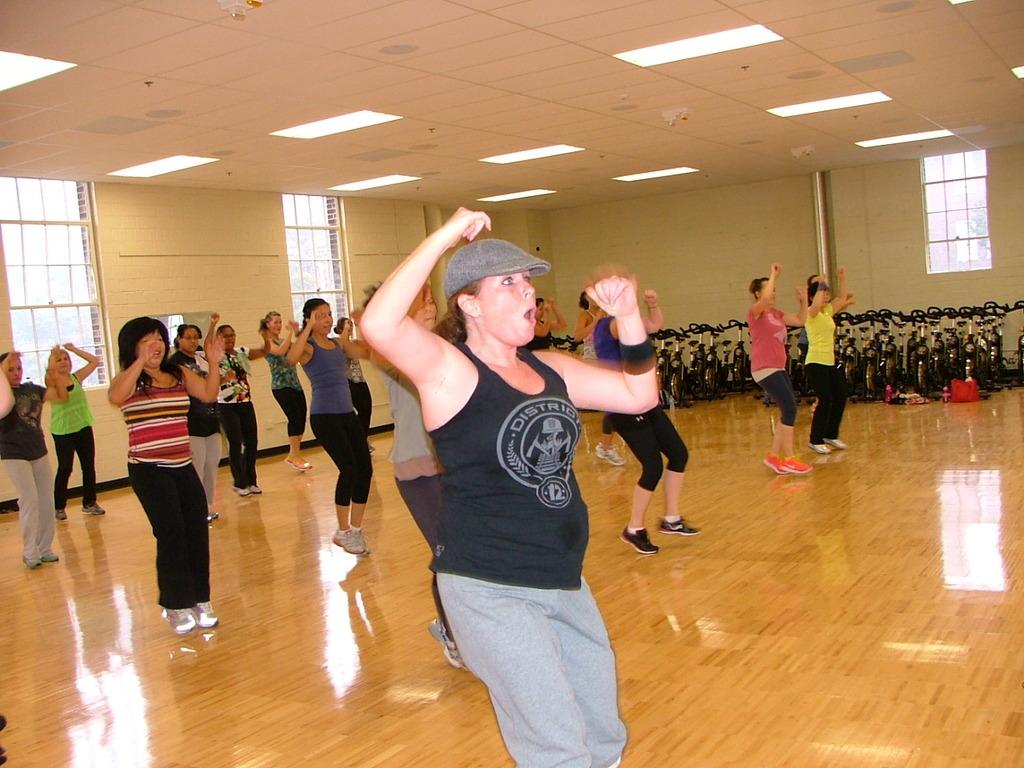What are the women in the image doing? The women in the image are jumping. What can be seen on the ceiling in the image? There are lights on the ceiling. What type of equipment is visible in the background of the image? There are exercise cycles in the background. What type of windows are present in the image? There are glass windows in the image. What letter is written on the cloud in the image? There is no cloud or letter present in the image. 